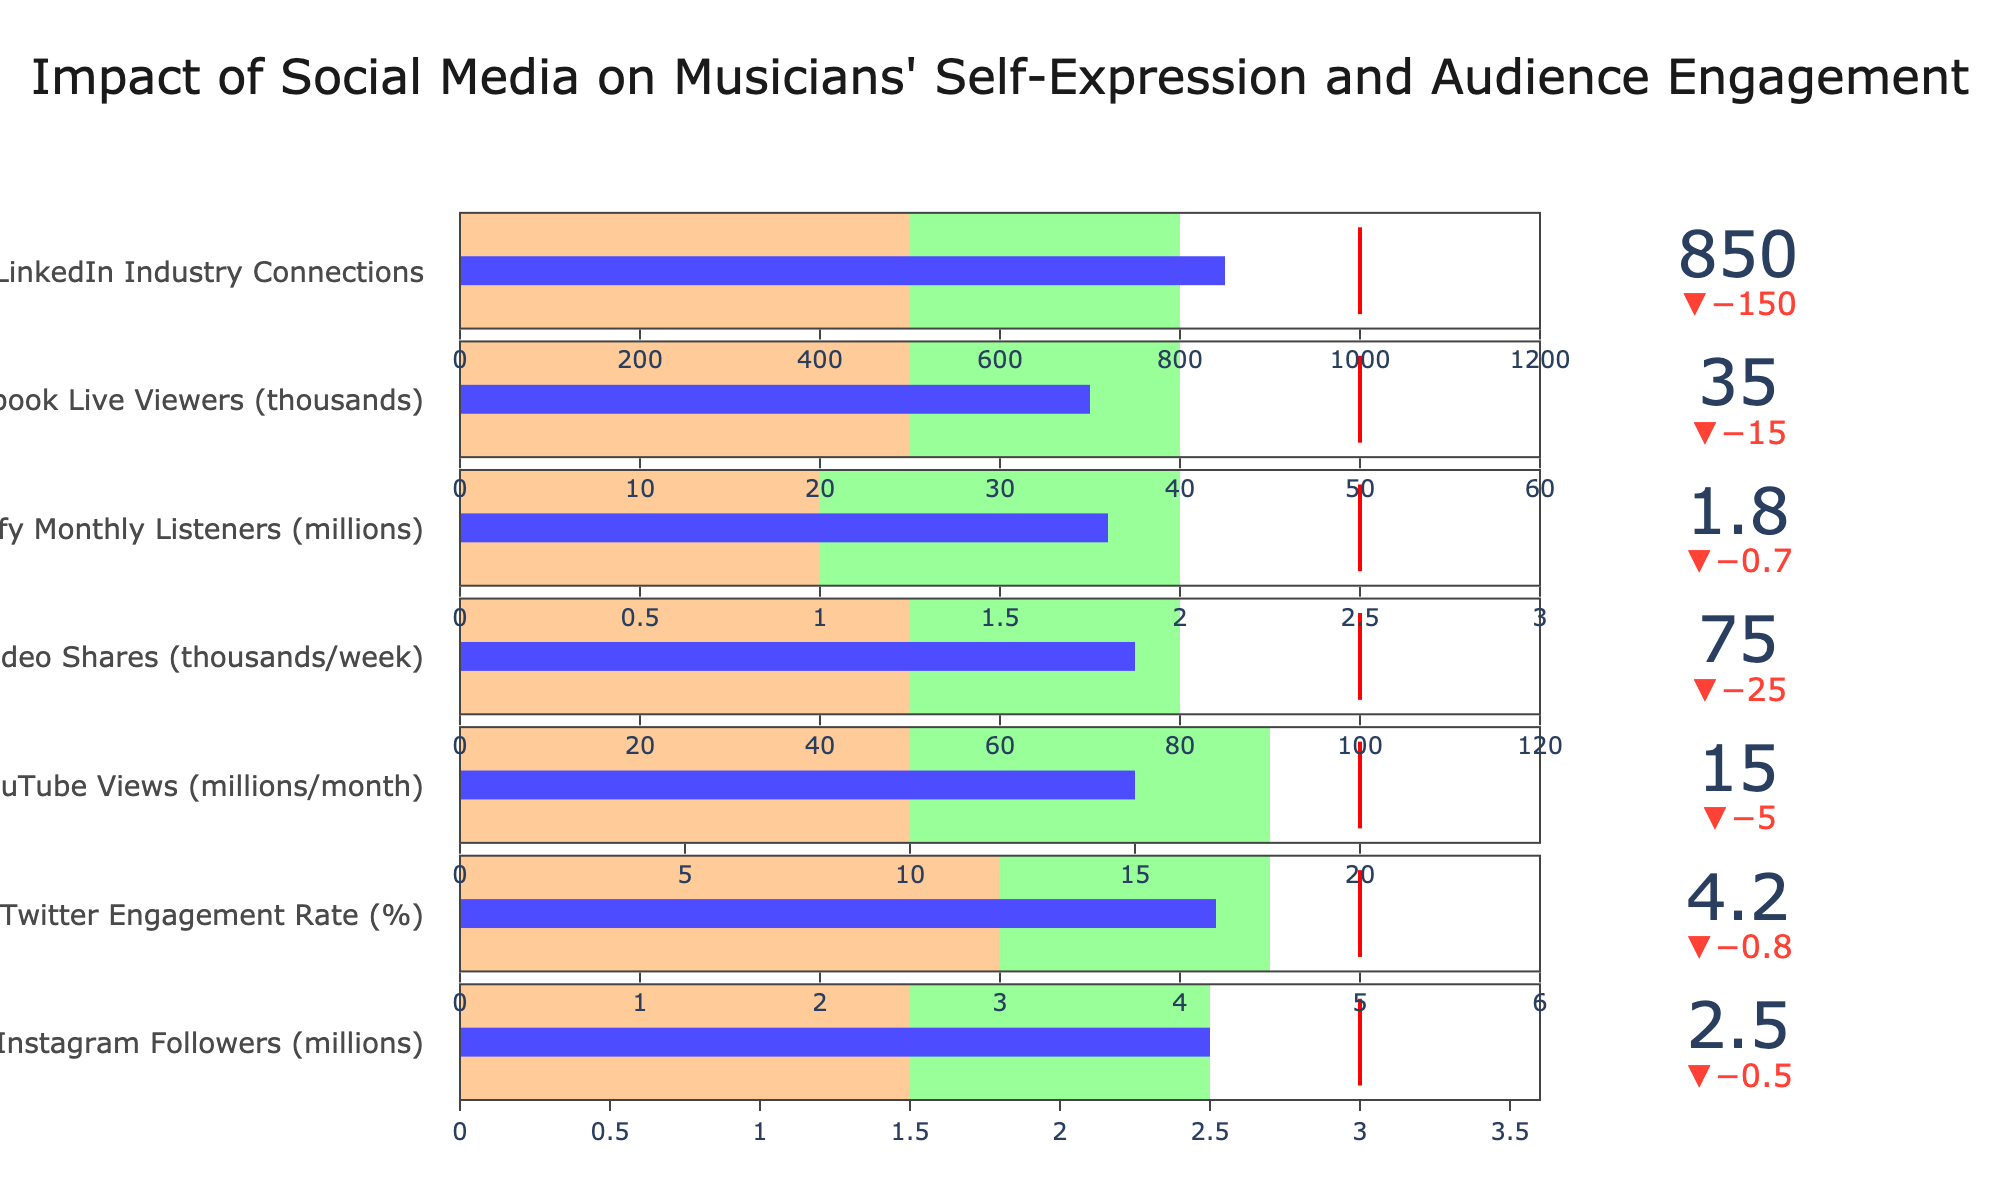What is the title of the figure? The title is usually found at the top of the chart and gives an overview of what the chart is about. In this case, it is described as "Impact of Social Media on Musicians' Self-Expression and Audience Engagement."
Answer: Impact of Social Media on Musicians' Self-Expression and Audience Engagement How many social media platforms are represented in the chart? Count the number of categories listed, each representing a different social media platform. The data provides information for Instagram, Twitter, YouTube, TikTok, Spotify, Facebook, and LinkedIn.
Answer: 7 What is the actual number of Instagram followers (in millions)? Locate the section labeled "Instagram Followers (millions)" and read the 'Actual' value associated with it.
Answer: 2.5 Which social media category has the highest actual value? Compare the 'Actual' values for all categories. The highest 'Actual' value is for YouTube Views.
Answer: YouTube Views Is the actual Twitter engagement rate higher or lower than its target? Compare the 'Actual' value for Twitter Engagement Rate with its 'Target.' Here, the actual value is 4.2%, and the target is 5%.
Answer: Lower What are the ranges for poor, satisfactory, and good performance for LinkedIn Industry Connections? Refer to the specific steps ranges for the LinkedIn category. Poor is 0 to 500, satisfactory is 500 to 800, and good is 800 to 1000.
Answer: Poor: 0-500, Satisfactory: 500-800, Good: 800-1000 What's the difference between the actual and target values for Spotify Monthly Listeners (in millions)? Subtract the 'Actual' value for Spotify Monthly Listeners from its 'Target' value (2.5 - 1.8).
Answer: 0.7 Which social media platform has the smallest gap between its actual value and its target? Compare the differences between the 'Actual' values and 'Target' values for all categories. LinkedIn Industry Connections has the smallest gap (150).
Answer: LinkedIn Industry Connections Are the actual values for TikTok Video Shares and Facebook Live Viewers within the 'good' range? Verify whether the actual values for both TikTok Video Shares (75) and Facebook Live Viewers (35) fall within their respective 'Good' ranges. TikTok Video Shares is within its 'good' range of 50-80, while Facebook Live Viewers is not within its 'good' range of 40-50.
Answer: TikTok: Yes, Facebook: No 